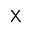Convert formula to latex. <formula><loc_0><loc_0><loc_500><loc_500>X</formula> 